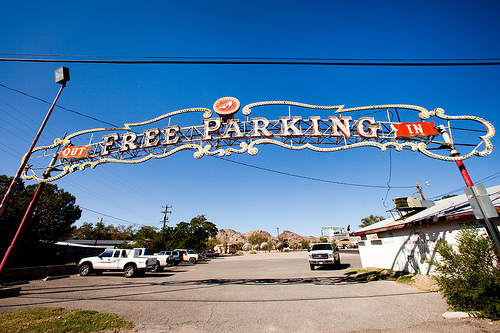<image>
Can you confirm if the sky is behind the car? Yes. From this viewpoint, the sky is positioned behind the car, with the car partially or fully occluding the sky. Is there a sign next to the truck? No. The sign is not positioned next to the truck. They are located in different areas of the scene. 